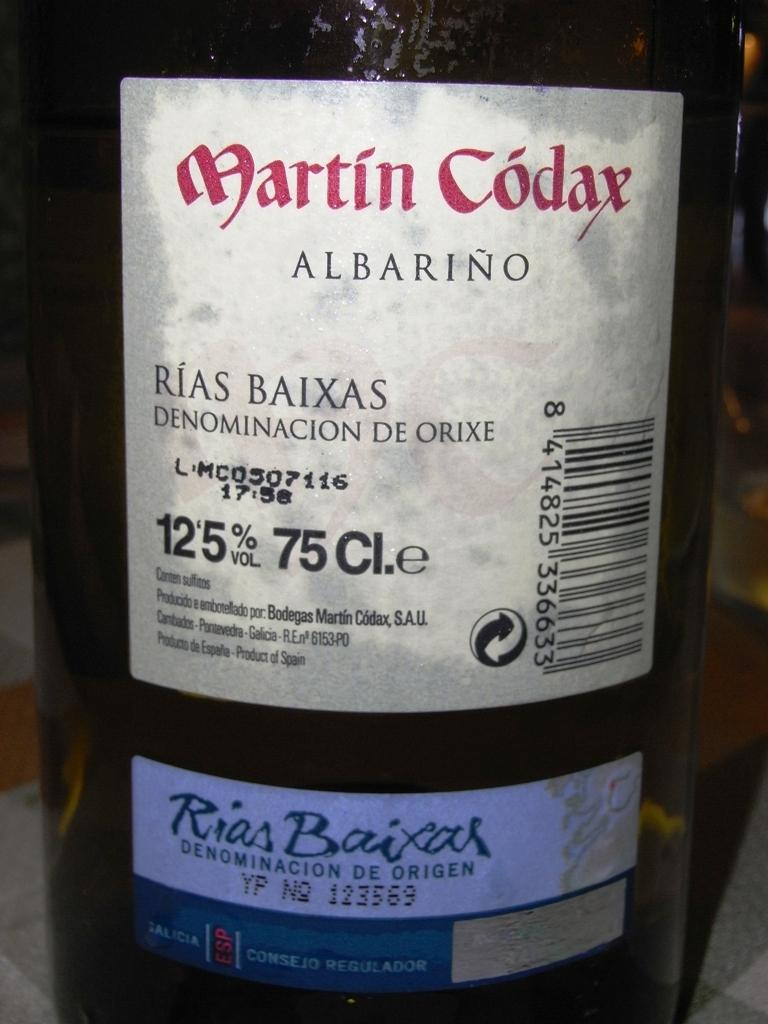<image>
Write a terse but informative summary of the picture. A bottle of wine with the label stating it is Martin Codax Albarino. 